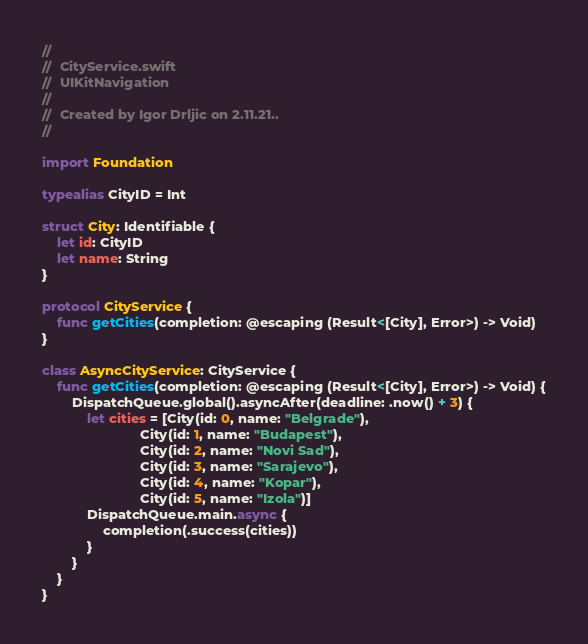Convert code to text. <code><loc_0><loc_0><loc_500><loc_500><_Swift_>//
//  CityService.swift
//  UIKitNavigation
//
//  Created by Igor Drljic on 2.11.21..
//

import Foundation

typealias CityID = Int

struct City: Identifiable {
    let id: CityID
    let name: String
}

protocol CityService {
    func getCities(completion: @escaping (Result<[City], Error>) -> Void)
}

class AsyncCityService: CityService {
    func getCities(completion: @escaping (Result<[City], Error>) -> Void) {
        DispatchQueue.global().asyncAfter(deadline: .now() + 3) {
            let cities = [City(id: 0, name: "Belgrade"),
                          City(id: 1, name: "Budapest"),
                          City(id: 2, name: "Novi Sad"),
                          City(id: 3, name: "Sarajevo"),
                          City(id: 4, name: "Kopar"),
                          City(id: 5, name: "Izola")]
            DispatchQueue.main.async {
                completion(.success(cities))
            }
        }
    }
}
</code> 